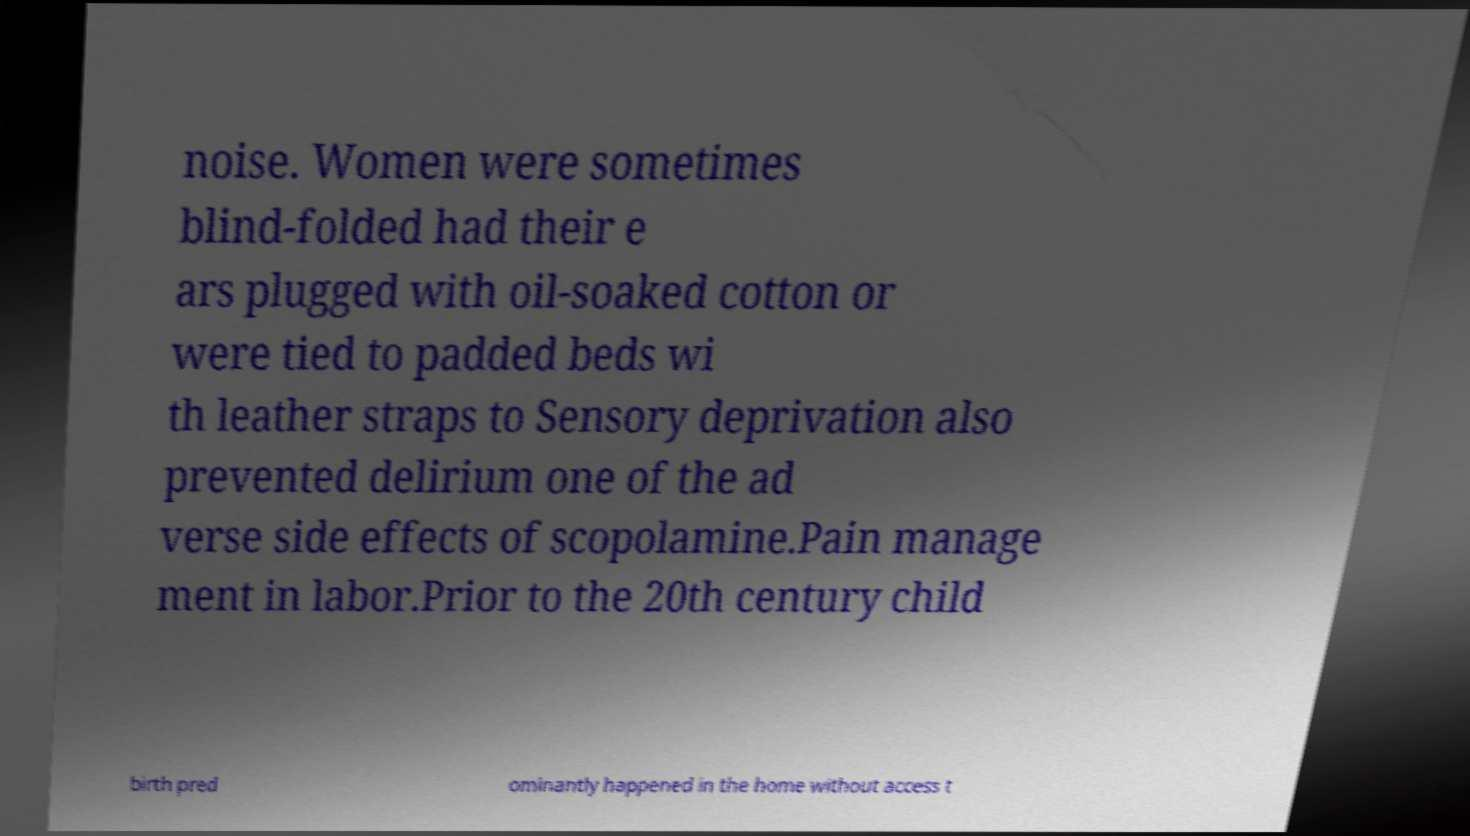Could you extract and type out the text from this image? noise. Women were sometimes blind-folded had their e ars plugged with oil-soaked cotton or were tied to padded beds wi th leather straps to Sensory deprivation also prevented delirium one of the ad verse side effects of scopolamine.Pain manage ment in labor.Prior to the 20th century child birth pred ominantly happened in the home without access t 